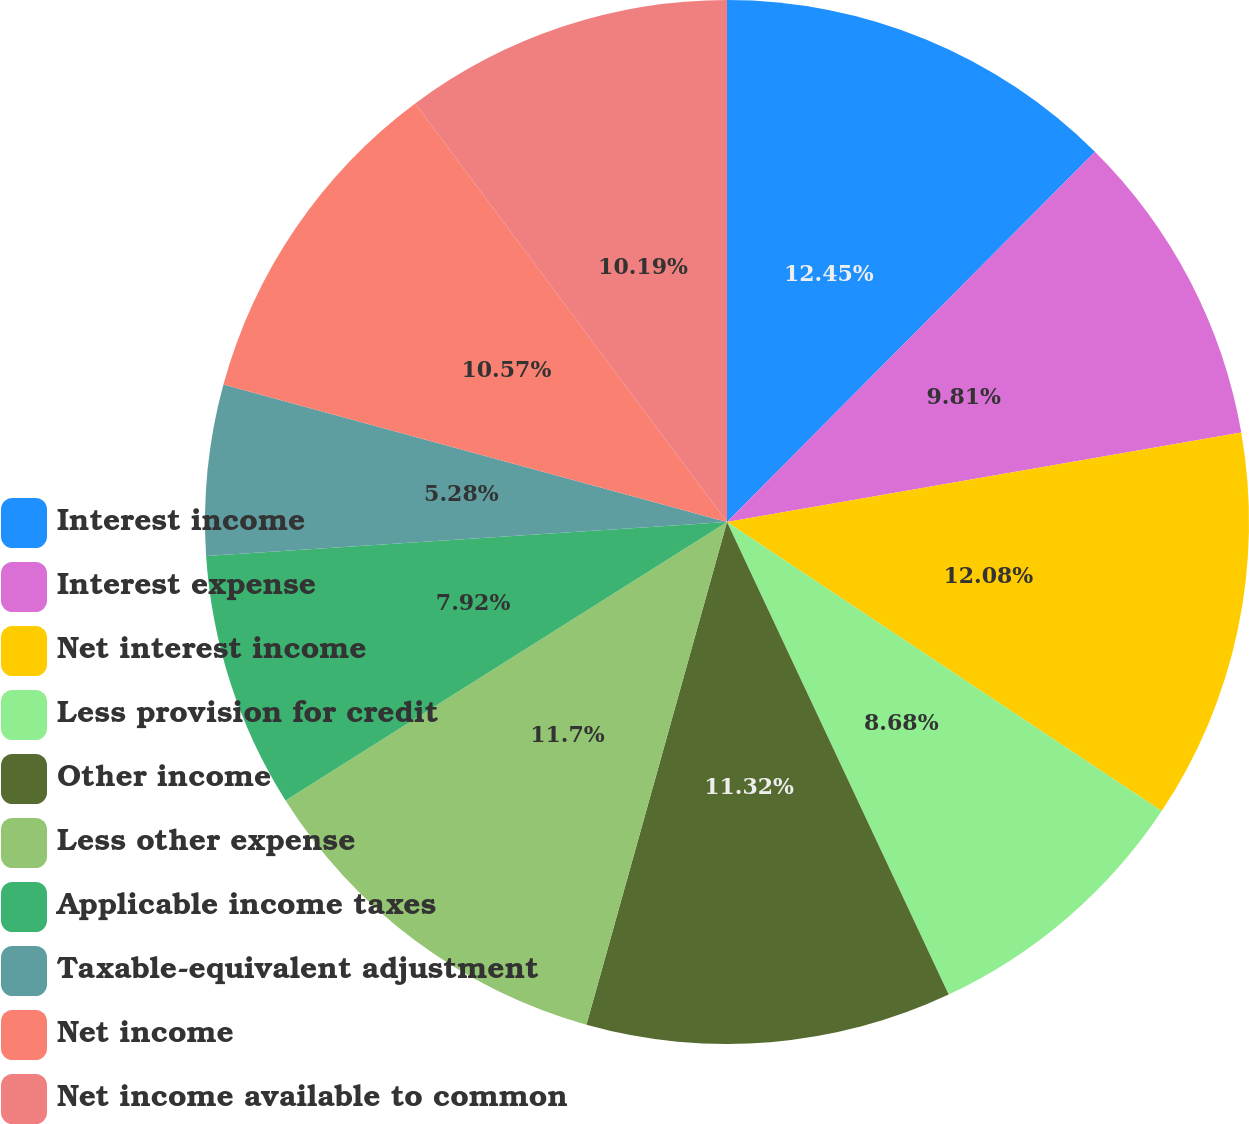Convert chart to OTSL. <chart><loc_0><loc_0><loc_500><loc_500><pie_chart><fcel>Interest income<fcel>Interest expense<fcel>Net interest income<fcel>Less provision for credit<fcel>Other income<fcel>Less other expense<fcel>Applicable income taxes<fcel>Taxable-equivalent adjustment<fcel>Net income<fcel>Net income available to common<nl><fcel>12.45%<fcel>9.81%<fcel>12.08%<fcel>8.68%<fcel>11.32%<fcel>11.7%<fcel>7.92%<fcel>5.28%<fcel>10.57%<fcel>10.19%<nl></chart> 